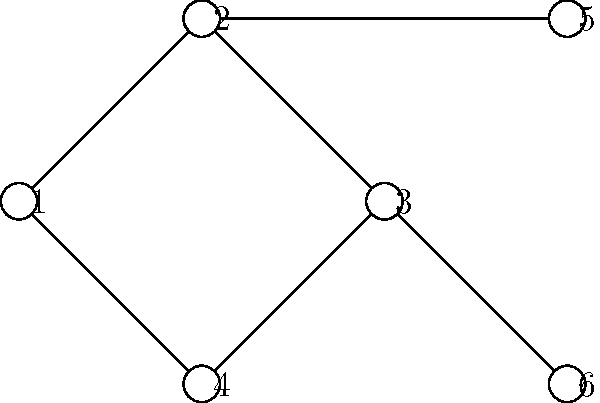As an engineering professor integrating computer science concepts, consider the network topology shown in the diagram. Which type of topology is represented, and what are the potential advantages and disadvantages of this configuration in a classroom setting for collaborative engineering projects? To answer this question, let's analyze the diagram step-by-step:

1. Observe the structure: The diagram shows 6 nodes connected in a specific pattern.

2. Identify the topology:
   - There is a central ring structure (nodes 1-2-3-4).
   - Two additional nodes (5 and 6) are connected to the ring.
   This configuration represents a hybrid topology, combining elements of a ring and a star topology.

3. Advantages in a classroom setting:
   a) Redundancy: The ring structure provides alternative paths for data, enhancing reliability.
   b) Expandability: Additional nodes (like 5 and 6) can be easily added to existing nodes.
   c) Distributed control: No single point of failure as in a pure star topology.

4. Disadvantages in a classroom setting:
   a) Complexity: More difficult to set up and manage compared to simpler topologies.
   b) Performance: Data might need to travel through multiple nodes, potentially causing delays.
   c) Cost: Requires more cables and network interfaces than a simple bus or star topology.

5. Application to collaborative engineering projects:
   - Supports multiple small groups (e.g., nodes 1-4) with additional resources or specialized workstations (nodes 5-6).
   - Allows for efficient communication within the ring while providing access to shared resources.

This topology combines the reliability of a ring with the expandability of a star, making it suitable for a dynamic classroom environment where both robustness and flexibility are valued.
Answer: Hybrid (ring-star) topology; advantages: redundancy, expandability, distributed control; disadvantages: complexity, potential delays, higher cost. 